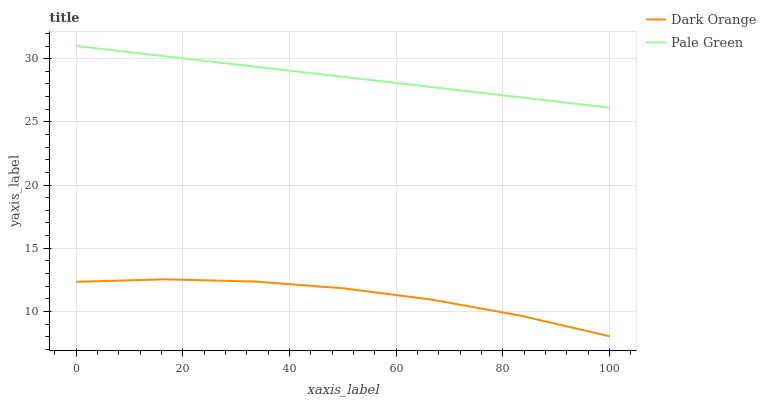Does Dark Orange have the minimum area under the curve?
Answer yes or no. Yes. Does Pale Green have the maximum area under the curve?
Answer yes or no. Yes. Does Pale Green have the minimum area under the curve?
Answer yes or no. No. Is Pale Green the smoothest?
Answer yes or no. Yes. Is Dark Orange the roughest?
Answer yes or no. Yes. Is Pale Green the roughest?
Answer yes or no. No. Does Pale Green have the lowest value?
Answer yes or no. No. Does Pale Green have the highest value?
Answer yes or no. Yes. Is Dark Orange less than Pale Green?
Answer yes or no. Yes. Is Pale Green greater than Dark Orange?
Answer yes or no. Yes. Does Dark Orange intersect Pale Green?
Answer yes or no. No. 